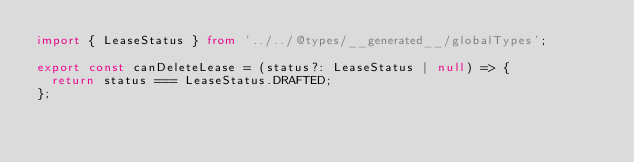Convert code to text. <code><loc_0><loc_0><loc_500><loc_500><_TypeScript_>import { LeaseStatus } from '../../@types/__generated__/globalTypes';

export const canDeleteLease = (status?: LeaseStatus | null) => {
  return status === LeaseStatus.DRAFTED;
};
</code> 